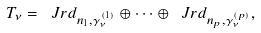Convert formula to latex. <formula><loc_0><loc_0><loc_500><loc_500>T _ { \nu } = \ J r d _ { n _ { 1 } , \gamma _ { \nu } ^ { ( 1 ) } } \oplus \cdots \oplus \ J r d _ { { n _ { p } , \gamma _ { \nu } ^ { ( p ) } } } ,</formula> 